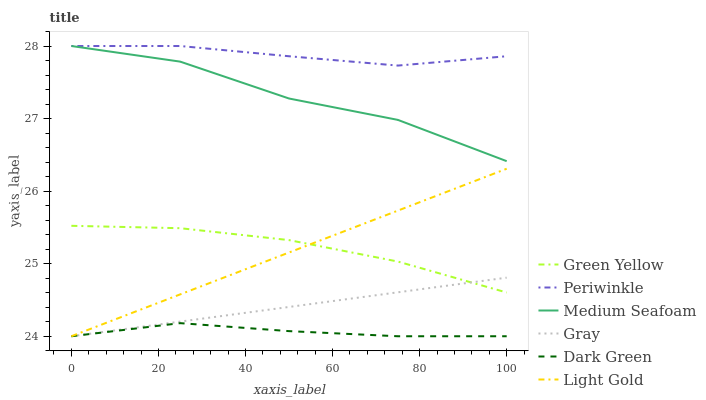Does Dark Green have the minimum area under the curve?
Answer yes or no. Yes. Does Periwinkle have the maximum area under the curve?
Answer yes or no. Yes. Does Green Yellow have the minimum area under the curve?
Answer yes or no. No. Does Green Yellow have the maximum area under the curve?
Answer yes or no. No. Is Gray the smoothest?
Answer yes or no. Yes. Is Medium Seafoam the roughest?
Answer yes or no. Yes. Is Periwinkle the smoothest?
Answer yes or no. No. Is Periwinkle the roughest?
Answer yes or no. No. Does Gray have the lowest value?
Answer yes or no. Yes. Does Green Yellow have the lowest value?
Answer yes or no. No. Does Medium Seafoam have the highest value?
Answer yes or no. Yes. Does Green Yellow have the highest value?
Answer yes or no. No. Is Gray less than Medium Seafoam?
Answer yes or no. Yes. Is Medium Seafoam greater than Light Gold?
Answer yes or no. Yes. Does Dark Green intersect Gray?
Answer yes or no. Yes. Is Dark Green less than Gray?
Answer yes or no. No. Is Dark Green greater than Gray?
Answer yes or no. No. Does Gray intersect Medium Seafoam?
Answer yes or no. No. 